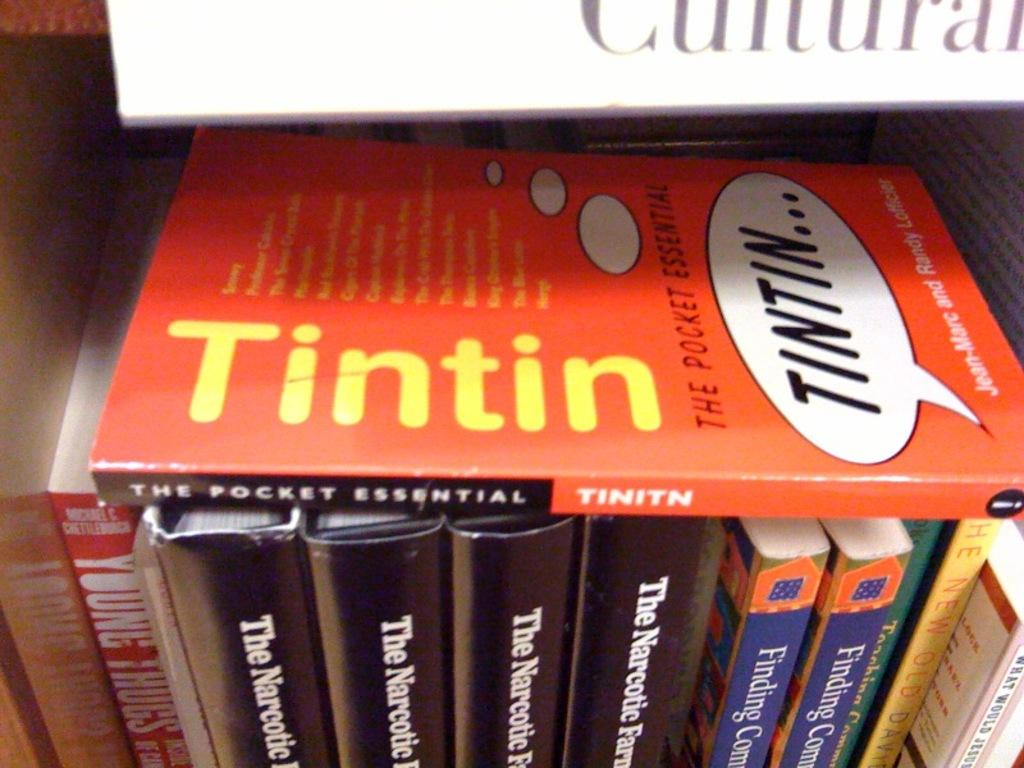<image>
Create a compact narrative representing the image presented. A book titled Tintin is on top of other books. 